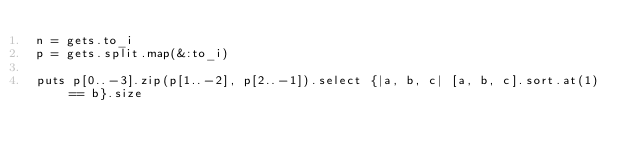<code> <loc_0><loc_0><loc_500><loc_500><_Ruby_>n = gets.to_i
p = gets.split.map(&:to_i)

puts p[0..-3].zip(p[1..-2], p[2..-1]).select {|a, b, c| [a, b, c].sort.at(1) == b}.size
</code> 